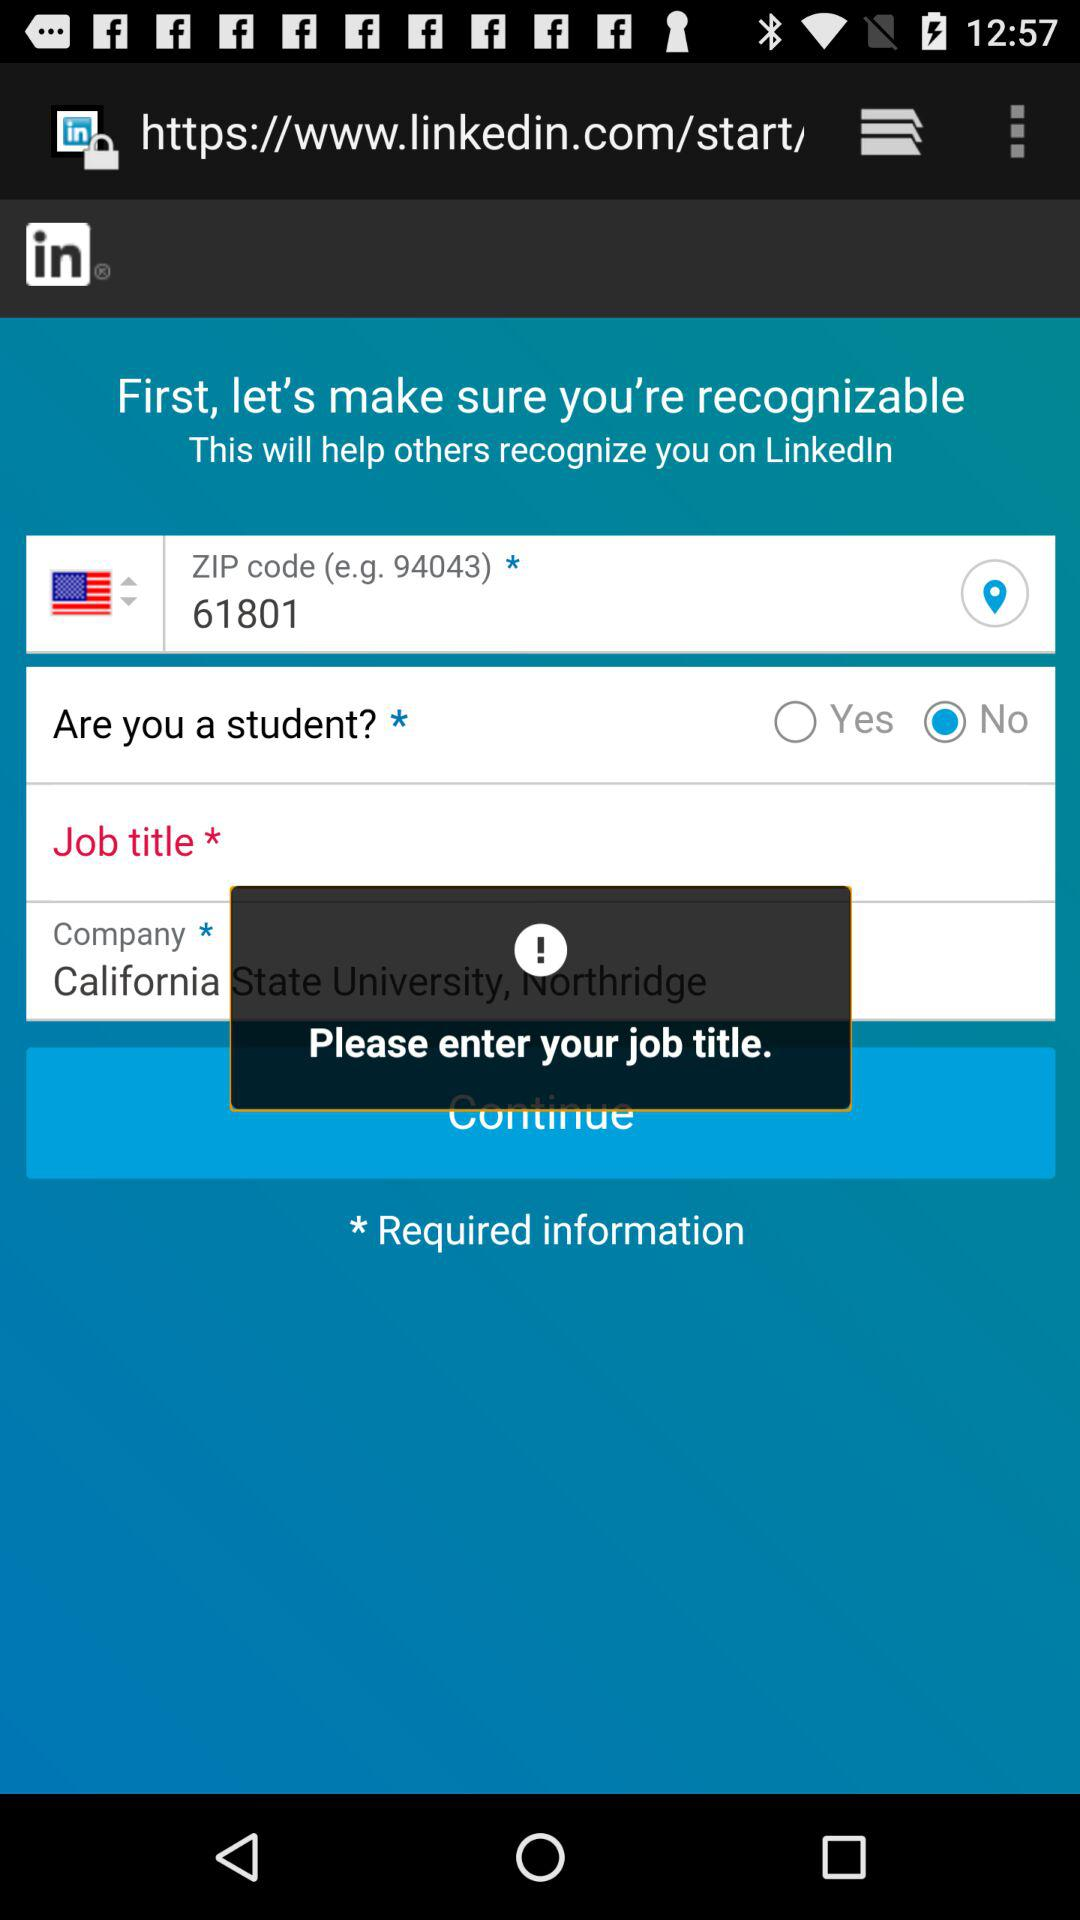How many text fields have a required asterisk next to them?
Answer the question using a single word or phrase. 3 